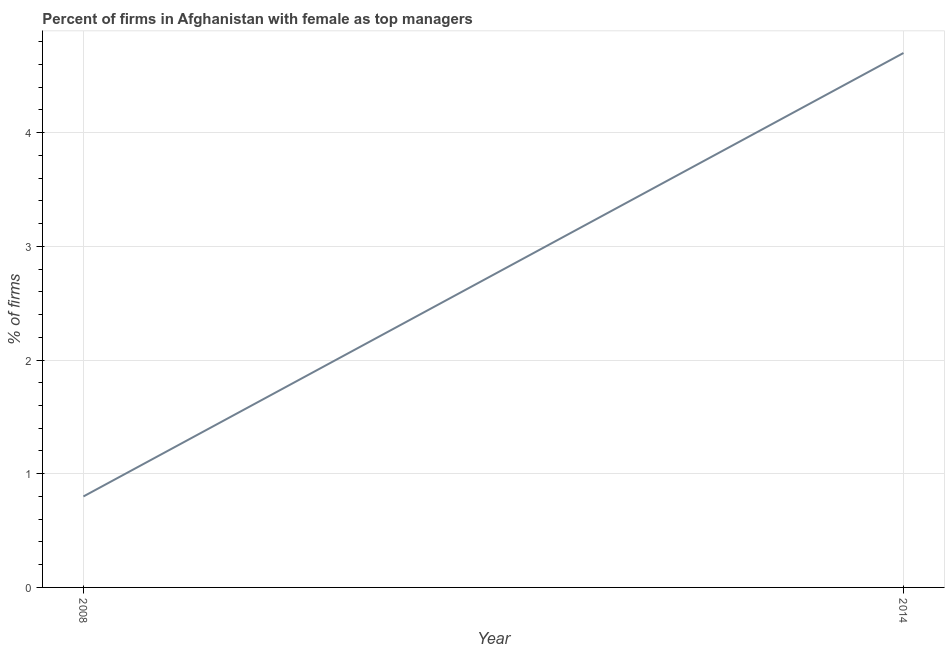What is the percentage of firms with female as top manager in 2008?
Your response must be concise. 0.8. Across all years, what is the minimum percentage of firms with female as top manager?
Provide a succinct answer. 0.8. In which year was the percentage of firms with female as top manager minimum?
Ensure brevity in your answer.  2008. What is the difference between the percentage of firms with female as top manager in 2008 and 2014?
Ensure brevity in your answer.  -3.9. What is the average percentage of firms with female as top manager per year?
Offer a very short reply. 2.75. What is the median percentage of firms with female as top manager?
Your answer should be compact. 2.75. In how many years, is the percentage of firms with female as top manager greater than 0.6000000000000001 %?
Provide a short and direct response. 2. What is the ratio of the percentage of firms with female as top manager in 2008 to that in 2014?
Keep it short and to the point. 0.17. In how many years, is the percentage of firms with female as top manager greater than the average percentage of firms with female as top manager taken over all years?
Ensure brevity in your answer.  1. How many lines are there?
Ensure brevity in your answer.  1. What is the difference between two consecutive major ticks on the Y-axis?
Your answer should be compact. 1. Are the values on the major ticks of Y-axis written in scientific E-notation?
Your answer should be very brief. No. Does the graph contain any zero values?
Your answer should be very brief. No. Does the graph contain grids?
Your answer should be compact. Yes. What is the title of the graph?
Your answer should be compact. Percent of firms in Afghanistan with female as top managers. What is the label or title of the X-axis?
Keep it short and to the point. Year. What is the label or title of the Y-axis?
Make the answer very short. % of firms. What is the % of firms of 2014?
Make the answer very short. 4.7. What is the ratio of the % of firms in 2008 to that in 2014?
Give a very brief answer. 0.17. 